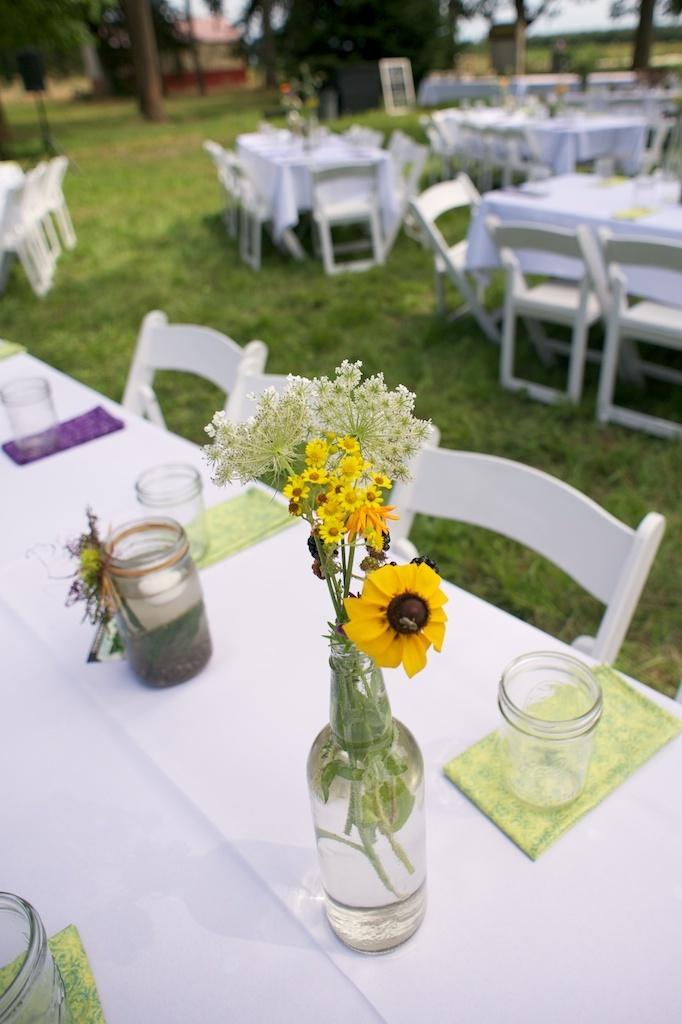Could you give a brief overview of what you see in this image? The image is clicked outside in the garden. I think tables and chairs are arranged for the dining. On every dining table there are some jars, glasses and flower vase. In the background there is a house and some trees. 